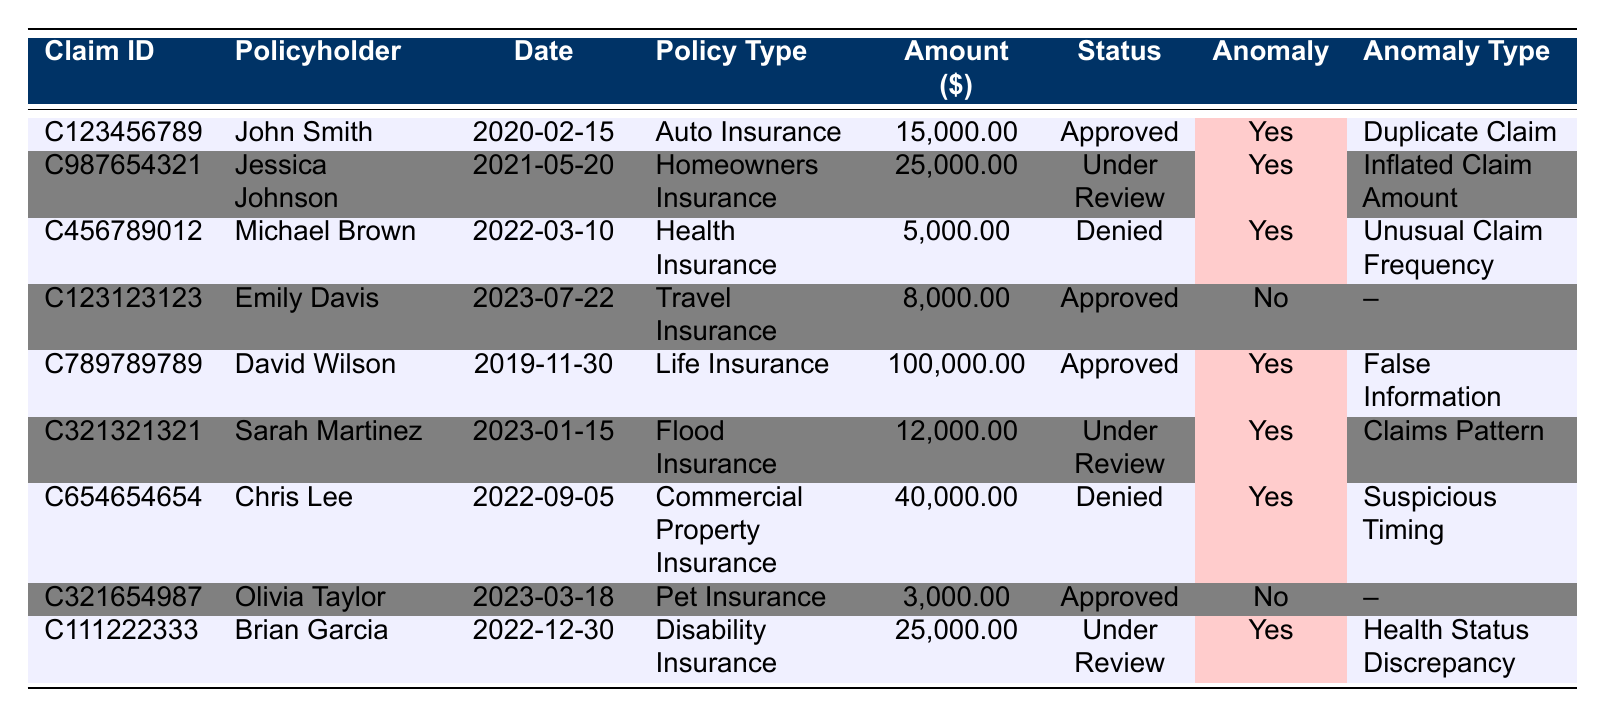What is the total claim amount for all approved claims? From the table, we can see the following approved claims and their amounts: John Smith ($15,000), David Wilson ($100,000), Emily Davis ($8,000), and Olivia Taylor ($3,000). We sum these amounts: 15,000 + 100,000 + 8,000 + 3,000 = 126,000.
Answer: 126,000 How many claims are flagged for anomalies? The table indicates which claims are flagged for anomalies. Counting the claims with "Yes" in the Anomaly column, we find there are five claims: John Smith, Jessica Johnson, Michael Brown, David Wilson, Sarah Martinez, Chris Lee, and Brian Garcia.
Answer: 5 Which policyholder has the largest claim amount flagged for an anomaly and what is that amount? Reviewing the table, we see that David Wilson has the largest flagged claim amount of $100,000.
Answer: David Wilson, 100,000 Is there a claim with both "Under Review" status and an anomaly flag? Yes, the claims for Jessica Johnson, Sarah Martinez, and Brian Garcia all have the status "Under Review" along with an anomaly flag.
Answer: Yes What is the difference in claim amounts between the largest and smallest flagged claims? The largest flagged claim amount is $100,000 (David Wilson) and the smallest flagged claim amount is $5,000 (Michael Brown). The difference is calculated as 100,000 - 5,000 = 95,000.
Answer: 95,000 What percentage of the total claims are flagged for anomalies? There are a total of 9 claims listed. Out of these, 5 claims are flagged for anomalies. To calculate the percentage, we use the formula (5/9) * 100 ≈ 55.56%.
Answer: 55.56% How many claims were submitted after 2021 but have anomalies? From the table, we see claims submitted after 2021 with anomalies are for Sarah Martinez (2023) and Brian Garcia (2022). Thus, there are two such claims.
Answer: 2 Which policy type has the highest number of flagged claims? By examining the table, we identify the policy types for flagged claims: Auto Insurance (1), Homeowners Insurance (1), Health Insurance (1), Life Insurance (1), Flood Insurance (1), and Commercial Property Insurance (1). All have only one flagged claim, hence no one policy type has more than others.
Answer: All equal Are there any denied claims with anomaly flags? Yes, there are denied claims flagged for anomalies. Michael Brown (Health Insurance) and Chris Lee (Commercial Property Insurance) both fall into this category.
Answer: Yes What is the investigation note for the claim flagged as "False Information"? The claim flagged as "False Information" belongs to David Wilson, and the investigation note states: "Discrepancy found in beneficiary details."
Answer: Discrepancy found in beneficiary details 